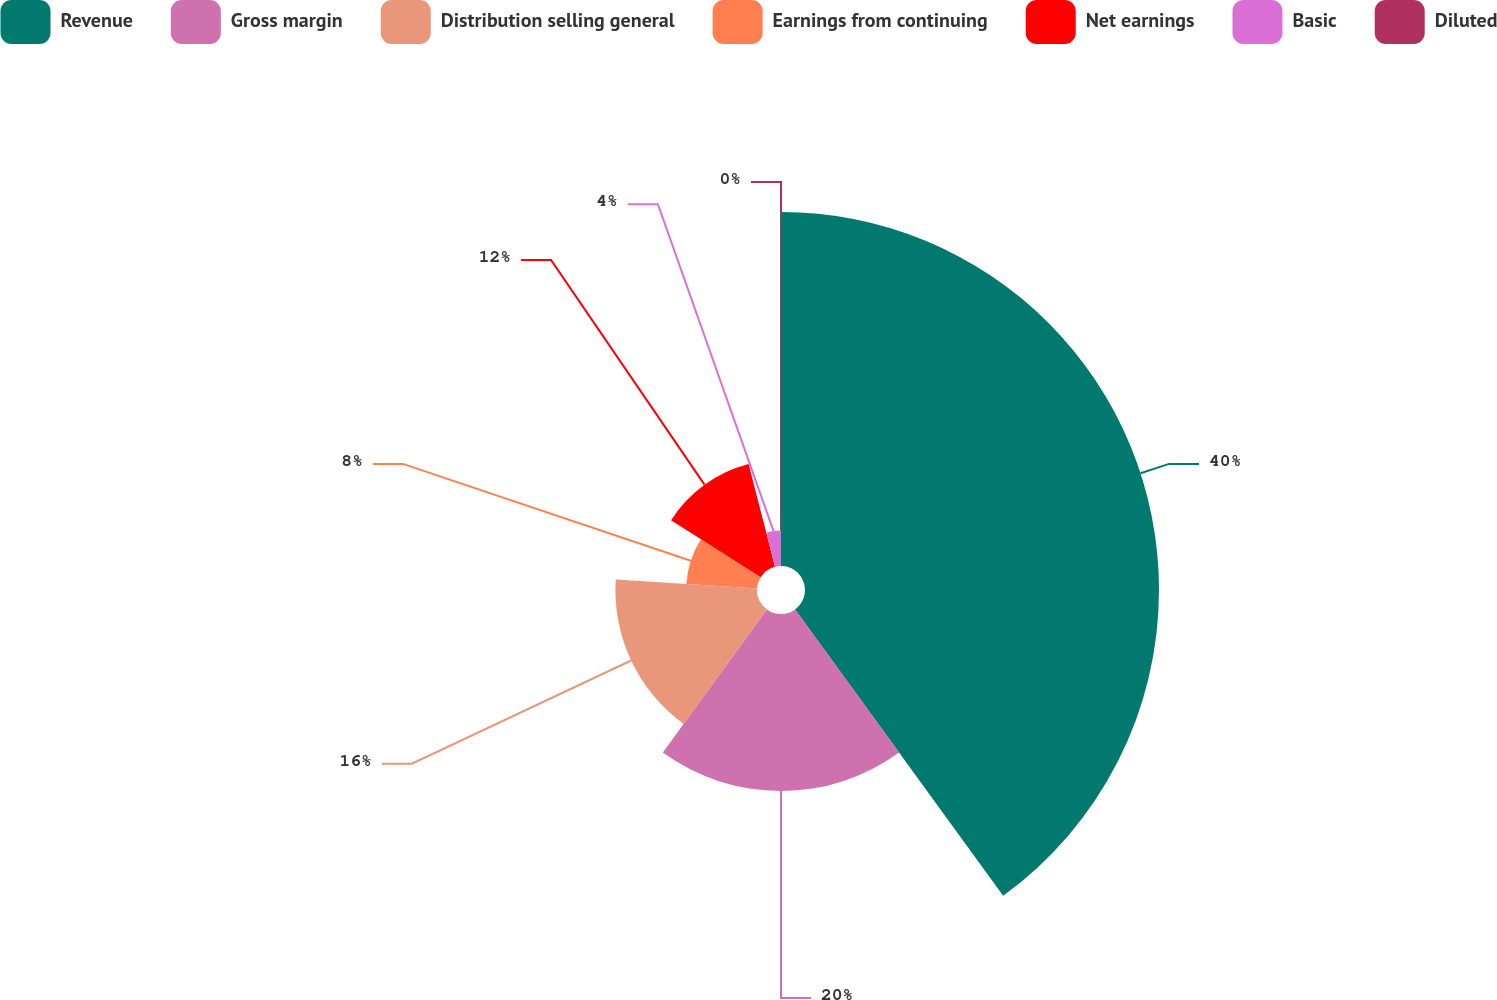<chart> <loc_0><loc_0><loc_500><loc_500><pie_chart><fcel>Revenue<fcel>Gross margin<fcel>Distribution selling general<fcel>Earnings from continuing<fcel>Net earnings<fcel>Basic<fcel>Diluted<nl><fcel>40.0%<fcel>20.0%<fcel>16.0%<fcel>8.0%<fcel>12.0%<fcel>4.0%<fcel>0.0%<nl></chart> 